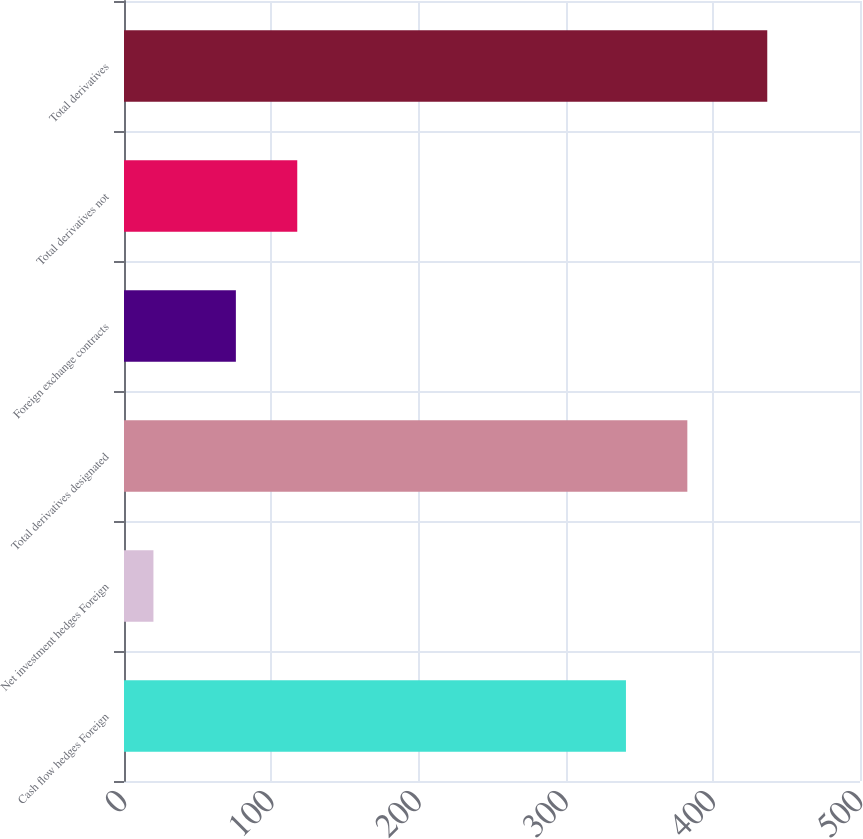Convert chart to OTSL. <chart><loc_0><loc_0><loc_500><loc_500><bar_chart><fcel>Cash flow hedges Foreign<fcel>Net investment hedges Foreign<fcel>Total derivatives designated<fcel>Foreign exchange contracts<fcel>Total derivatives not<fcel>Total derivatives<nl><fcel>341<fcel>20<fcel>382.7<fcel>76<fcel>117.7<fcel>437<nl></chart> 